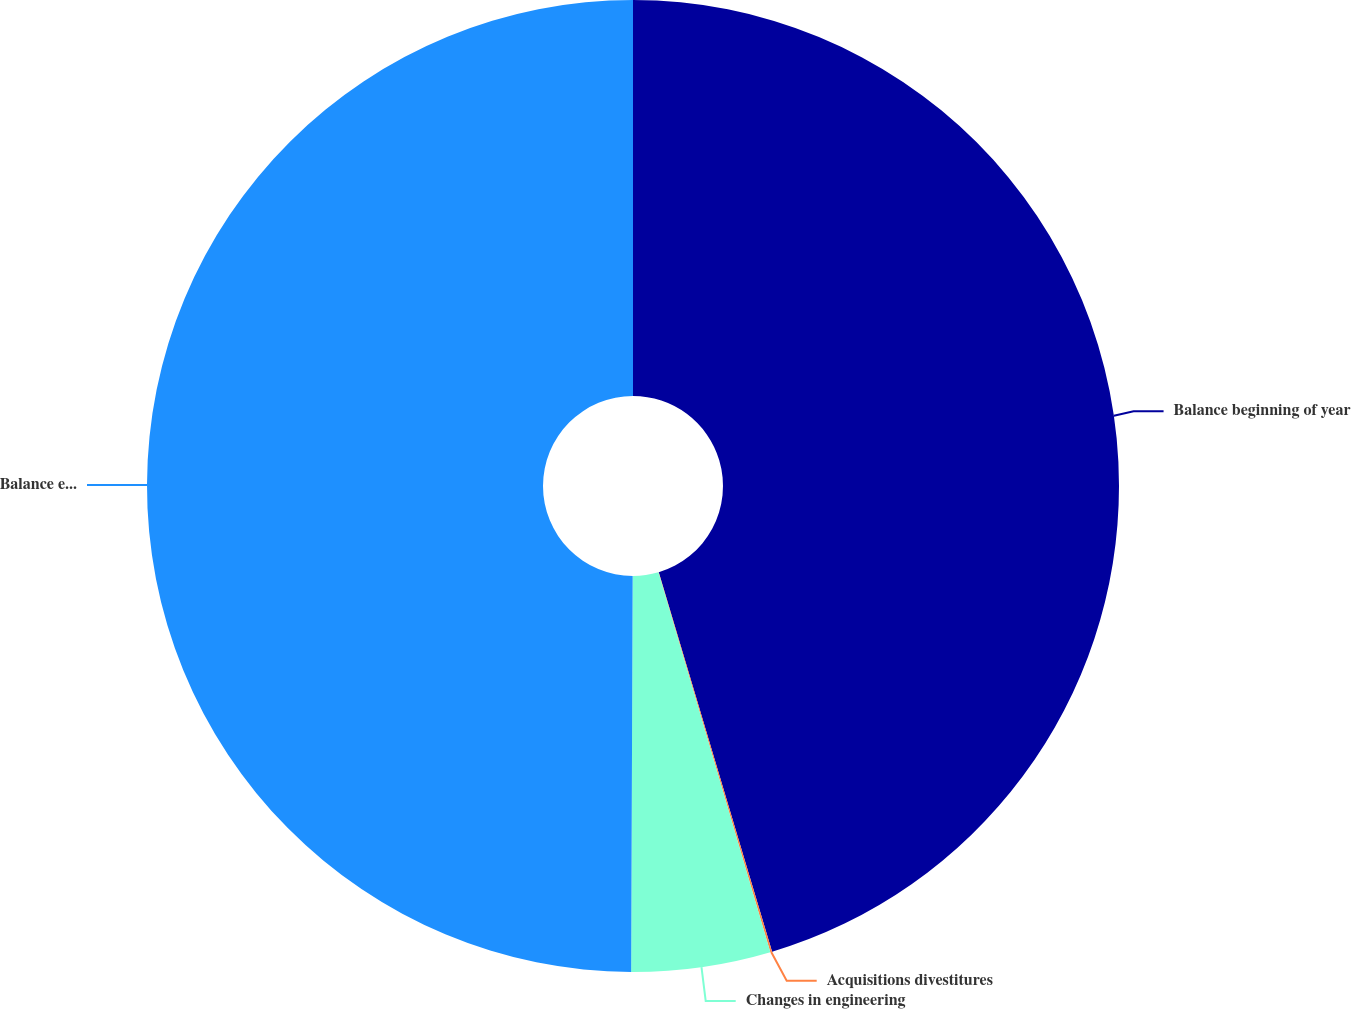Convert chart. <chart><loc_0><loc_0><loc_500><loc_500><pie_chart><fcel>Balance beginning of year<fcel>Acquisitions divestitures<fcel>Changes in engineering<fcel>Balance end of year<nl><fcel>45.38%<fcel>0.06%<fcel>4.62%<fcel>49.94%<nl></chart> 